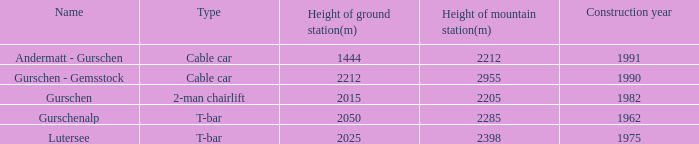How much Height of ground station(m) has a Name of lutersee, and a Height of mountain station(m) larger than 2398? 0.0. 